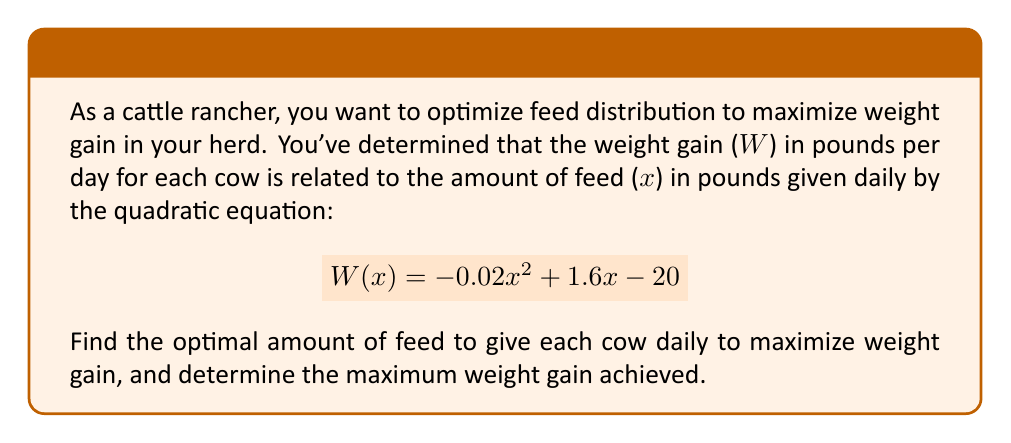Show me your answer to this math problem. To find the optimal amount of feed and maximum weight gain, we need to find the vertex of the quadratic function. The steps are as follows:

1) The quadratic function is in the form $$W(x) = ax^2 + bx + c$$
   where $a = -0.02$, $b = 1.6$, and $c = -20$

2) For a quadratic function, the x-coordinate of the vertex is given by $x = -\frac{b}{2a}$

3) Substituting our values:
   $$x = -\frac{1.6}{2(-0.02)} = -\frac{1.6}{-0.04} = 40$$

4) This means the optimal amount of feed is 40 pounds per day.

5) To find the maximum weight gain, we substitute x = 40 into our original equation:
   $$W(40) = -0.02(40)^2 + 1.6(40) - 20$$
   $$= -0.02(1600) + 64 - 20$$
   $$= -32 + 64 - 20$$
   $$= 12$$

Therefore, the maximum weight gain is 12 pounds per day.
Answer: Optimal feed: 40 lbs/day; Maximum weight gain: 12 lbs/day 